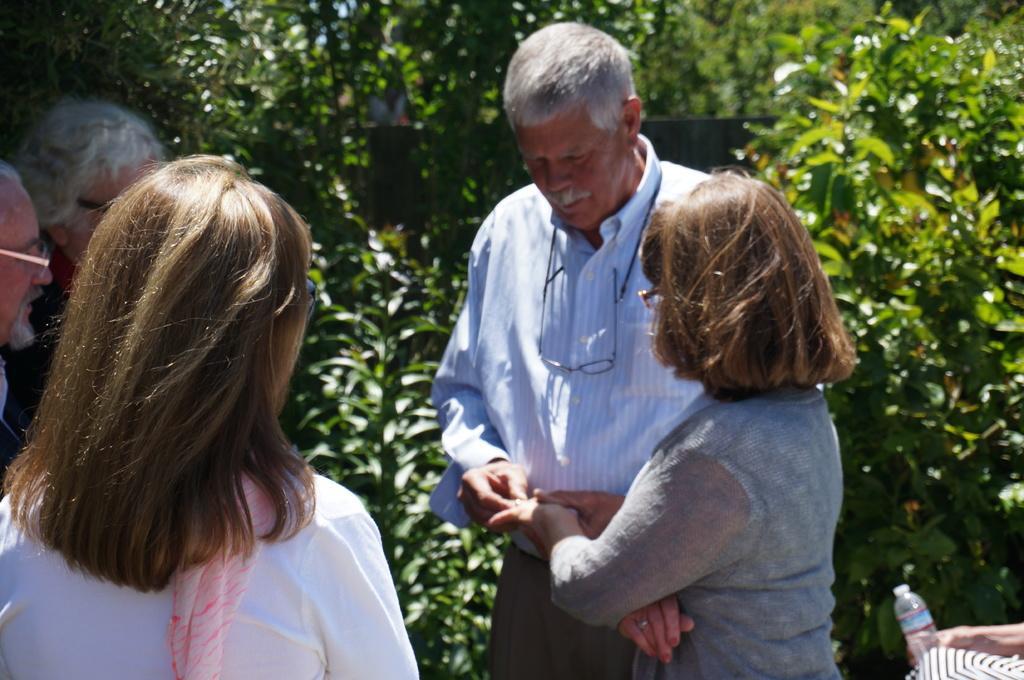Describe this image in one or two sentences. There are people standing. Background we can see trees. 